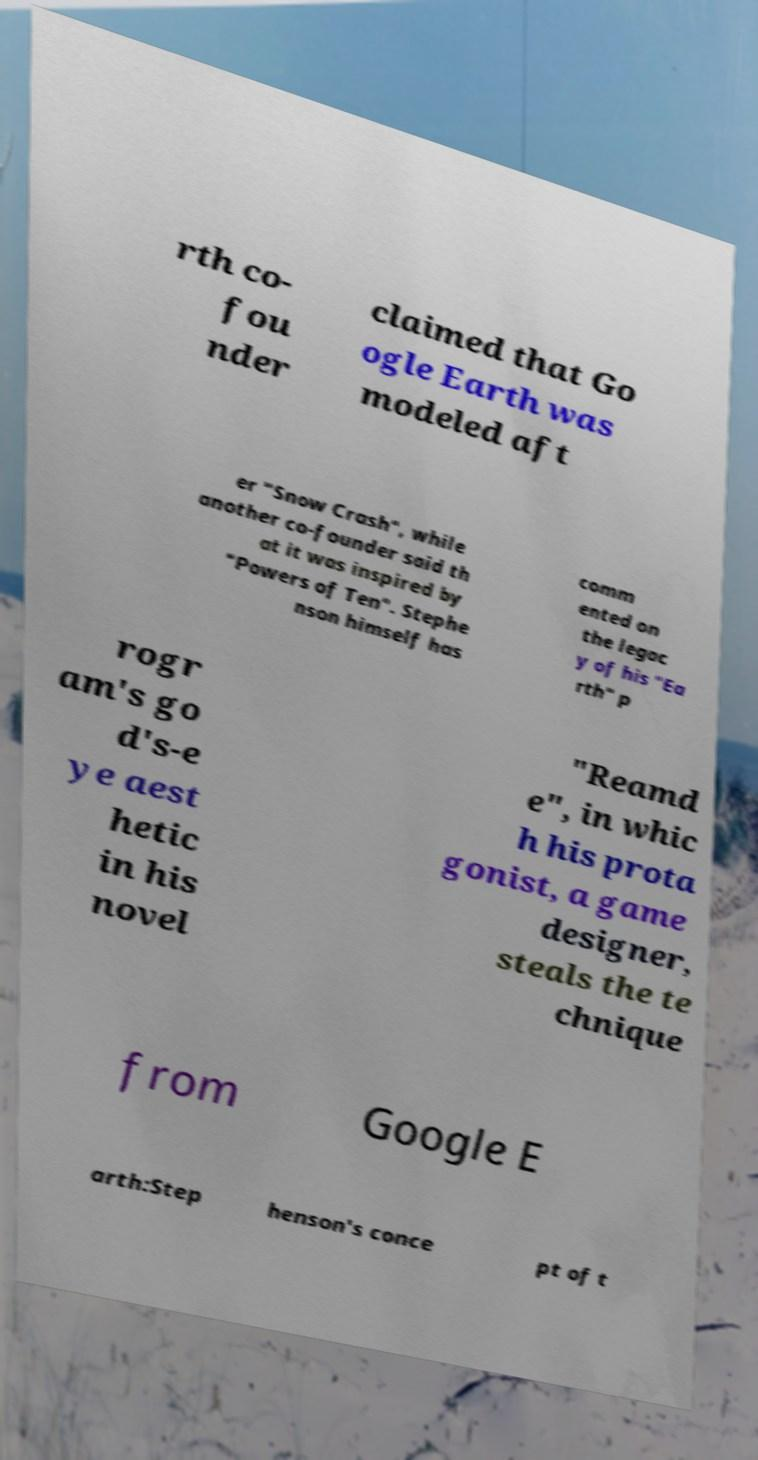Can you read and provide the text displayed in the image?This photo seems to have some interesting text. Can you extract and type it out for me? rth co- fou nder claimed that Go ogle Earth was modeled aft er "Snow Crash", while another co-founder said th at it was inspired by "Powers of Ten". Stephe nson himself has comm ented on the legac y of his "Ea rth" p rogr am's go d's-e ye aest hetic in his novel "Reamd e", in whic h his prota gonist, a game designer, steals the te chnique from Google E arth:Step henson's conce pt of t 